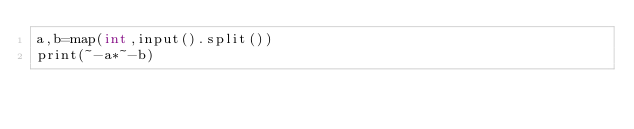Convert code to text. <code><loc_0><loc_0><loc_500><loc_500><_Cython_>a,b=map(int,input().split())
print(~-a*~-b)</code> 